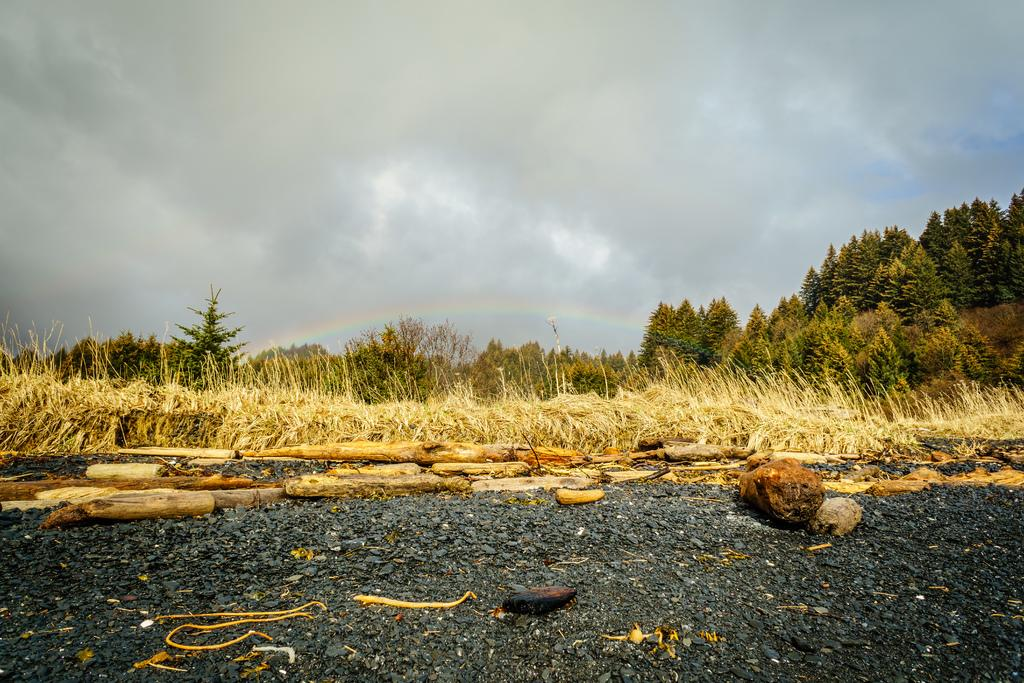What type of natural elements can be seen in the image? There are stones in the image. What can be seen in the background of the image? There is dried grass and trees with green leaves in the background of the image. What is the color of the sky in the image? The sky is blue and white in color. What type of pear is hanging from the tree in the image? There is no pear present in the image; it features stones, dried grass, trees with green leaves, and a blue and white sky. 